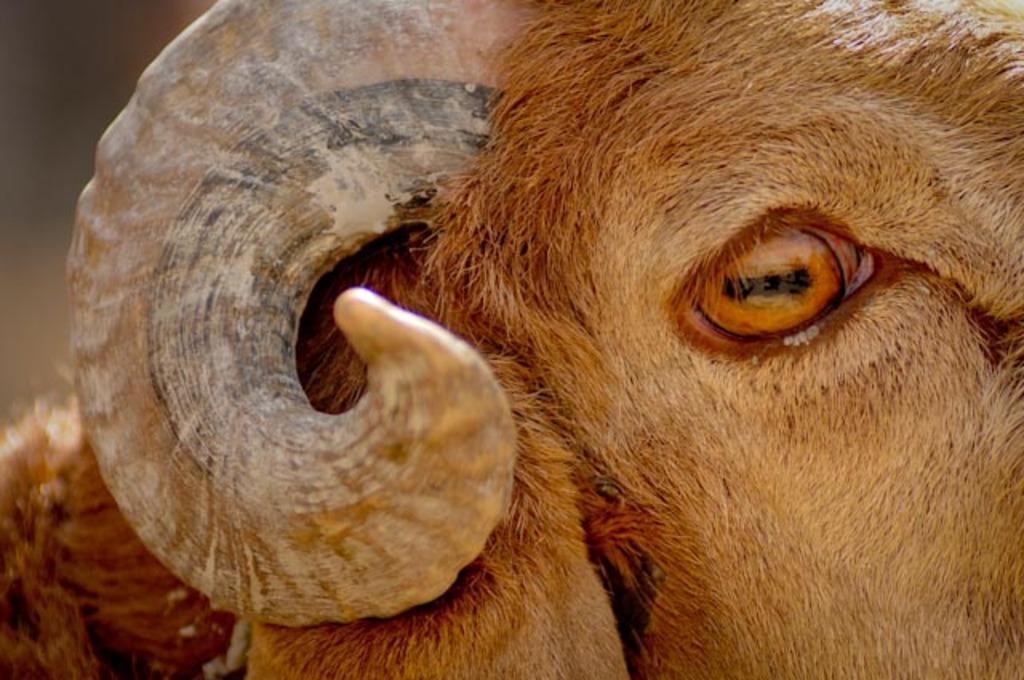In one or two sentences, can you explain what this image depicts? In the image we can see there is a horn and eye of a sheep. 